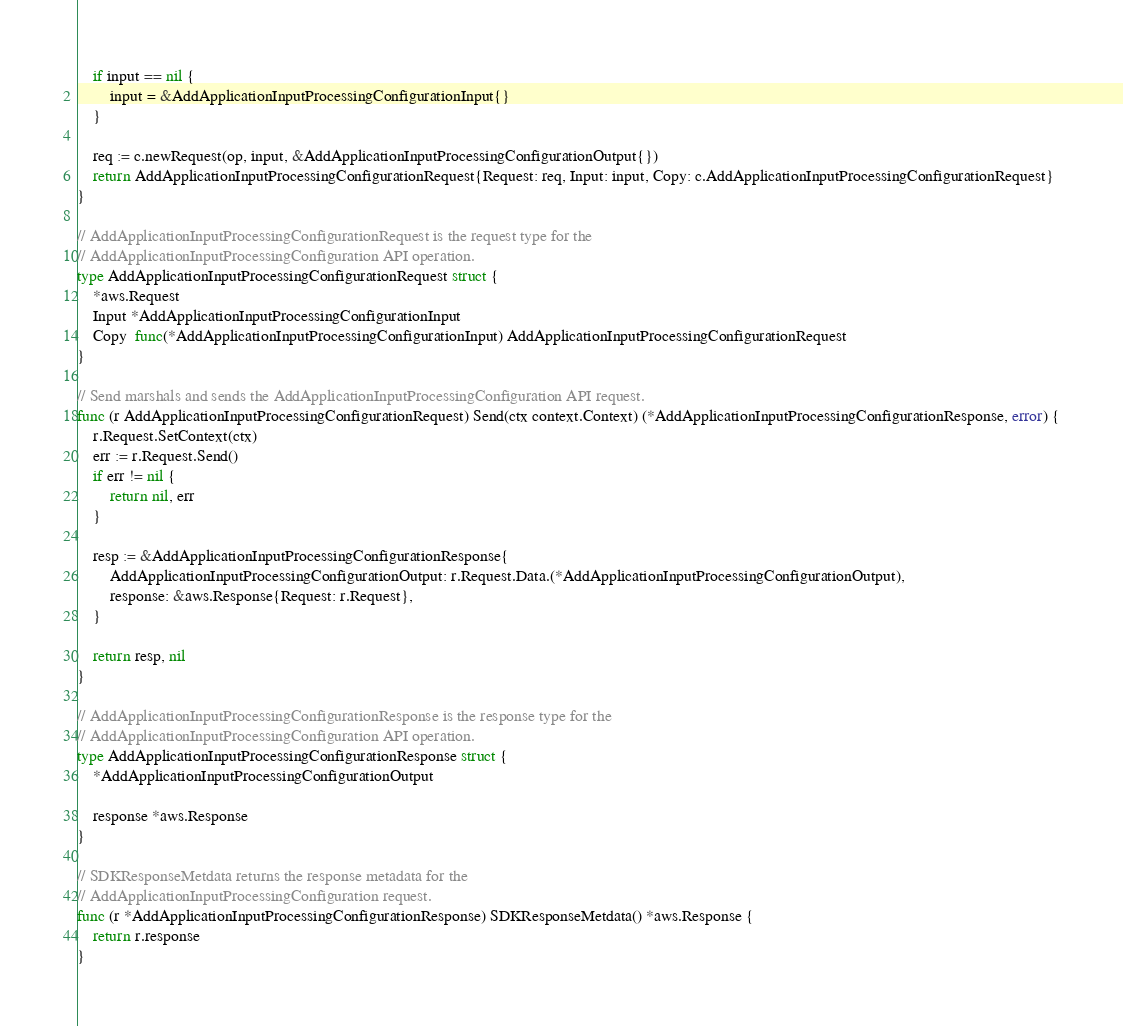Convert code to text. <code><loc_0><loc_0><loc_500><loc_500><_Go_>
	if input == nil {
		input = &AddApplicationInputProcessingConfigurationInput{}
	}

	req := c.newRequest(op, input, &AddApplicationInputProcessingConfigurationOutput{})
	return AddApplicationInputProcessingConfigurationRequest{Request: req, Input: input, Copy: c.AddApplicationInputProcessingConfigurationRequest}
}

// AddApplicationInputProcessingConfigurationRequest is the request type for the
// AddApplicationInputProcessingConfiguration API operation.
type AddApplicationInputProcessingConfigurationRequest struct {
	*aws.Request
	Input *AddApplicationInputProcessingConfigurationInput
	Copy  func(*AddApplicationInputProcessingConfigurationInput) AddApplicationInputProcessingConfigurationRequest
}

// Send marshals and sends the AddApplicationInputProcessingConfiguration API request.
func (r AddApplicationInputProcessingConfigurationRequest) Send(ctx context.Context) (*AddApplicationInputProcessingConfigurationResponse, error) {
	r.Request.SetContext(ctx)
	err := r.Request.Send()
	if err != nil {
		return nil, err
	}

	resp := &AddApplicationInputProcessingConfigurationResponse{
		AddApplicationInputProcessingConfigurationOutput: r.Request.Data.(*AddApplicationInputProcessingConfigurationOutput),
		response: &aws.Response{Request: r.Request},
	}

	return resp, nil
}

// AddApplicationInputProcessingConfigurationResponse is the response type for the
// AddApplicationInputProcessingConfiguration API operation.
type AddApplicationInputProcessingConfigurationResponse struct {
	*AddApplicationInputProcessingConfigurationOutput

	response *aws.Response
}

// SDKResponseMetdata returns the response metadata for the
// AddApplicationInputProcessingConfiguration request.
func (r *AddApplicationInputProcessingConfigurationResponse) SDKResponseMetdata() *aws.Response {
	return r.response
}
</code> 